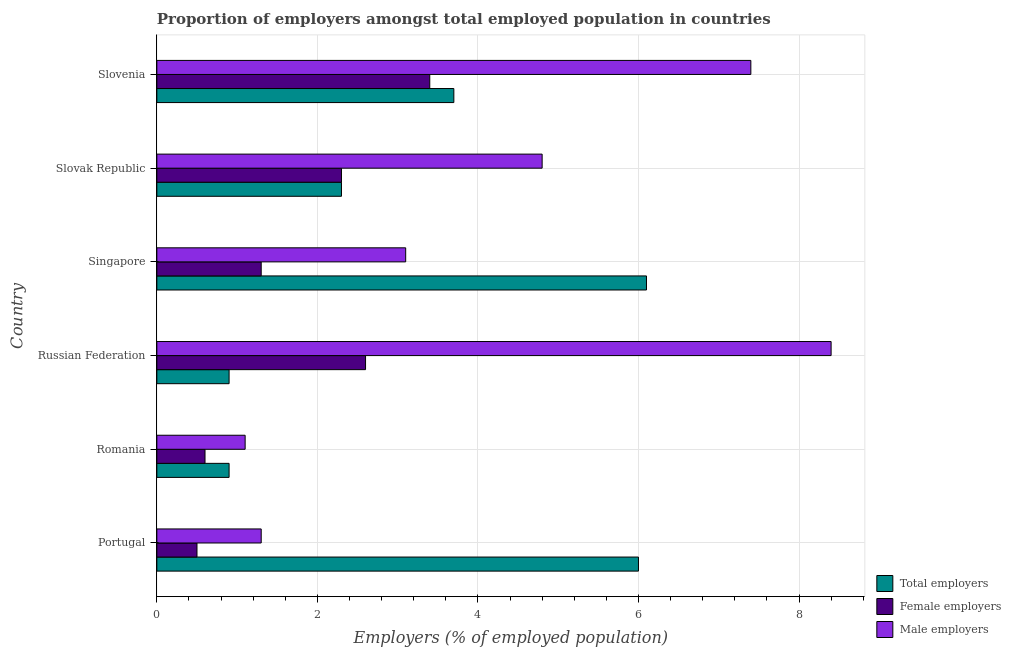How many different coloured bars are there?
Your response must be concise. 3. Are the number of bars per tick equal to the number of legend labels?
Give a very brief answer. Yes. What is the label of the 2nd group of bars from the top?
Provide a succinct answer. Slovak Republic. What is the percentage of total employers in Slovak Republic?
Your answer should be compact. 2.3. Across all countries, what is the maximum percentage of male employers?
Make the answer very short. 8.4. Across all countries, what is the minimum percentage of male employers?
Give a very brief answer. 1.1. In which country was the percentage of female employers maximum?
Offer a very short reply. Slovenia. In which country was the percentage of female employers minimum?
Provide a short and direct response. Portugal. What is the total percentage of female employers in the graph?
Your answer should be very brief. 10.7. What is the difference between the percentage of male employers in Russian Federation and the percentage of total employers in Slovenia?
Keep it short and to the point. 4.7. What is the average percentage of total employers per country?
Your answer should be very brief. 3.32. What is the difference between the percentage of total employers and percentage of female employers in Slovenia?
Make the answer very short. 0.3. Is the percentage of female employers in Portugal less than that in Singapore?
Your answer should be compact. Yes. What is the difference between the highest and the second highest percentage of female employers?
Your answer should be very brief. 0.8. What is the difference between the highest and the lowest percentage of male employers?
Provide a short and direct response. 7.3. What does the 1st bar from the top in Portugal represents?
Keep it short and to the point. Male employers. What does the 2nd bar from the bottom in Singapore represents?
Ensure brevity in your answer.  Female employers. Is it the case that in every country, the sum of the percentage of total employers and percentage of female employers is greater than the percentage of male employers?
Provide a short and direct response. No. How many bars are there?
Provide a short and direct response. 18. Are all the bars in the graph horizontal?
Keep it short and to the point. Yes. How many countries are there in the graph?
Keep it short and to the point. 6. Are the values on the major ticks of X-axis written in scientific E-notation?
Keep it short and to the point. No. Does the graph contain any zero values?
Provide a succinct answer. No. Does the graph contain grids?
Offer a very short reply. Yes. How many legend labels are there?
Offer a very short reply. 3. How are the legend labels stacked?
Provide a short and direct response. Vertical. What is the title of the graph?
Your response must be concise. Proportion of employers amongst total employed population in countries. Does "Maunufacturing" appear as one of the legend labels in the graph?
Keep it short and to the point. No. What is the label or title of the X-axis?
Offer a terse response. Employers (% of employed population). What is the label or title of the Y-axis?
Make the answer very short. Country. What is the Employers (% of employed population) in Female employers in Portugal?
Provide a short and direct response. 0.5. What is the Employers (% of employed population) in Male employers in Portugal?
Make the answer very short. 1.3. What is the Employers (% of employed population) of Total employers in Romania?
Your answer should be very brief. 0.9. What is the Employers (% of employed population) of Female employers in Romania?
Your answer should be very brief. 0.6. What is the Employers (% of employed population) of Male employers in Romania?
Keep it short and to the point. 1.1. What is the Employers (% of employed population) in Total employers in Russian Federation?
Provide a succinct answer. 0.9. What is the Employers (% of employed population) of Female employers in Russian Federation?
Give a very brief answer. 2.6. What is the Employers (% of employed population) in Male employers in Russian Federation?
Keep it short and to the point. 8.4. What is the Employers (% of employed population) of Total employers in Singapore?
Keep it short and to the point. 6.1. What is the Employers (% of employed population) of Female employers in Singapore?
Your answer should be very brief. 1.3. What is the Employers (% of employed population) in Male employers in Singapore?
Provide a short and direct response. 3.1. What is the Employers (% of employed population) of Total employers in Slovak Republic?
Your answer should be compact. 2.3. What is the Employers (% of employed population) of Female employers in Slovak Republic?
Offer a very short reply. 2.3. What is the Employers (% of employed population) in Male employers in Slovak Republic?
Your answer should be compact. 4.8. What is the Employers (% of employed population) of Total employers in Slovenia?
Provide a succinct answer. 3.7. What is the Employers (% of employed population) of Female employers in Slovenia?
Keep it short and to the point. 3.4. What is the Employers (% of employed population) in Male employers in Slovenia?
Offer a terse response. 7.4. Across all countries, what is the maximum Employers (% of employed population) in Total employers?
Ensure brevity in your answer.  6.1. Across all countries, what is the maximum Employers (% of employed population) of Female employers?
Give a very brief answer. 3.4. Across all countries, what is the maximum Employers (% of employed population) of Male employers?
Offer a very short reply. 8.4. Across all countries, what is the minimum Employers (% of employed population) in Total employers?
Offer a terse response. 0.9. Across all countries, what is the minimum Employers (% of employed population) of Male employers?
Give a very brief answer. 1.1. What is the total Employers (% of employed population) in Total employers in the graph?
Make the answer very short. 19.9. What is the total Employers (% of employed population) of Male employers in the graph?
Provide a short and direct response. 26.1. What is the difference between the Employers (% of employed population) in Female employers in Portugal and that in Romania?
Keep it short and to the point. -0.1. What is the difference between the Employers (% of employed population) in Male employers in Portugal and that in Romania?
Your answer should be very brief. 0.2. What is the difference between the Employers (% of employed population) of Female employers in Portugal and that in Russian Federation?
Make the answer very short. -2.1. What is the difference between the Employers (% of employed population) of Total employers in Portugal and that in Singapore?
Give a very brief answer. -0.1. What is the difference between the Employers (% of employed population) of Total employers in Portugal and that in Slovenia?
Provide a succinct answer. 2.3. What is the difference between the Employers (% of employed population) of Female employers in Portugal and that in Slovenia?
Offer a terse response. -2.9. What is the difference between the Employers (% of employed population) in Male employers in Romania and that in Russian Federation?
Your response must be concise. -7.3. What is the difference between the Employers (% of employed population) of Female employers in Romania and that in Singapore?
Make the answer very short. -0.7. What is the difference between the Employers (% of employed population) of Male employers in Romania and that in Singapore?
Offer a terse response. -2. What is the difference between the Employers (% of employed population) of Total employers in Romania and that in Slovak Republic?
Offer a terse response. -1.4. What is the difference between the Employers (% of employed population) in Female employers in Romania and that in Slovak Republic?
Your response must be concise. -1.7. What is the difference between the Employers (% of employed population) in Total employers in Romania and that in Slovenia?
Make the answer very short. -2.8. What is the difference between the Employers (% of employed population) in Female employers in Romania and that in Slovenia?
Your response must be concise. -2.8. What is the difference between the Employers (% of employed population) of Total employers in Russian Federation and that in Singapore?
Your answer should be very brief. -5.2. What is the difference between the Employers (% of employed population) of Male employers in Russian Federation and that in Singapore?
Provide a short and direct response. 5.3. What is the difference between the Employers (% of employed population) in Total employers in Russian Federation and that in Slovenia?
Ensure brevity in your answer.  -2.8. What is the difference between the Employers (% of employed population) of Female employers in Russian Federation and that in Slovenia?
Give a very brief answer. -0.8. What is the difference between the Employers (% of employed population) of Male employers in Singapore and that in Slovak Republic?
Your response must be concise. -1.7. What is the difference between the Employers (% of employed population) of Total employers in Singapore and that in Slovenia?
Keep it short and to the point. 2.4. What is the difference between the Employers (% of employed population) of Total employers in Portugal and the Employers (% of employed population) of Female employers in Romania?
Give a very brief answer. 5.4. What is the difference between the Employers (% of employed population) of Total employers in Portugal and the Employers (% of employed population) of Male employers in Romania?
Keep it short and to the point. 4.9. What is the difference between the Employers (% of employed population) in Total employers in Portugal and the Employers (% of employed population) in Female employers in Russian Federation?
Offer a terse response. 3.4. What is the difference between the Employers (% of employed population) of Total employers in Portugal and the Employers (% of employed population) of Male employers in Russian Federation?
Give a very brief answer. -2.4. What is the difference between the Employers (% of employed population) of Female employers in Portugal and the Employers (% of employed population) of Male employers in Russian Federation?
Give a very brief answer. -7.9. What is the difference between the Employers (% of employed population) of Total employers in Portugal and the Employers (% of employed population) of Male employers in Singapore?
Give a very brief answer. 2.9. What is the difference between the Employers (% of employed population) of Female employers in Portugal and the Employers (% of employed population) of Male employers in Singapore?
Make the answer very short. -2.6. What is the difference between the Employers (% of employed population) in Total employers in Portugal and the Employers (% of employed population) in Female employers in Slovak Republic?
Ensure brevity in your answer.  3.7. What is the difference between the Employers (% of employed population) of Female employers in Portugal and the Employers (% of employed population) of Male employers in Slovak Republic?
Make the answer very short. -4.3. What is the difference between the Employers (% of employed population) of Female employers in Portugal and the Employers (% of employed population) of Male employers in Slovenia?
Keep it short and to the point. -6.9. What is the difference between the Employers (% of employed population) of Total employers in Romania and the Employers (% of employed population) of Male employers in Russian Federation?
Your answer should be very brief. -7.5. What is the difference between the Employers (% of employed population) of Female employers in Romania and the Employers (% of employed population) of Male employers in Russian Federation?
Your answer should be very brief. -7.8. What is the difference between the Employers (% of employed population) in Total employers in Romania and the Employers (% of employed population) in Female employers in Singapore?
Provide a short and direct response. -0.4. What is the difference between the Employers (% of employed population) of Total employers in Romania and the Employers (% of employed population) of Male employers in Singapore?
Offer a terse response. -2.2. What is the difference between the Employers (% of employed population) in Total employers in Romania and the Employers (% of employed population) in Female employers in Slovak Republic?
Offer a terse response. -1.4. What is the difference between the Employers (% of employed population) of Total employers in Romania and the Employers (% of employed population) of Male employers in Slovak Republic?
Offer a terse response. -3.9. What is the difference between the Employers (% of employed population) in Female employers in Romania and the Employers (% of employed population) in Male employers in Slovak Republic?
Provide a succinct answer. -4.2. What is the difference between the Employers (% of employed population) in Total employers in Russian Federation and the Employers (% of employed population) in Male employers in Singapore?
Your answer should be compact. -2.2. What is the difference between the Employers (% of employed population) of Female employers in Russian Federation and the Employers (% of employed population) of Male employers in Singapore?
Ensure brevity in your answer.  -0.5. What is the difference between the Employers (% of employed population) in Total employers in Russian Federation and the Employers (% of employed population) in Male employers in Slovenia?
Offer a terse response. -6.5. What is the difference between the Employers (% of employed population) in Total employers in Singapore and the Employers (% of employed population) in Female employers in Slovak Republic?
Offer a very short reply. 3.8. What is the difference between the Employers (% of employed population) of Total employers in Singapore and the Employers (% of employed population) of Male employers in Slovenia?
Provide a short and direct response. -1.3. What is the average Employers (% of employed population) of Total employers per country?
Provide a succinct answer. 3.32. What is the average Employers (% of employed population) of Female employers per country?
Keep it short and to the point. 1.78. What is the average Employers (% of employed population) of Male employers per country?
Your response must be concise. 4.35. What is the difference between the Employers (% of employed population) in Total employers and Employers (% of employed population) in Male employers in Portugal?
Offer a terse response. 4.7. What is the difference between the Employers (% of employed population) of Total employers and Employers (% of employed population) of Female employers in Romania?
Make the answer very short. 0.3. What is the difference between the Employers (% of employed population) of Total employers and Employers (% of employed population) of Male employers in Russian Federation?
Make the answer very short. -7.5. What is the difference between the Employers (% of employed population) in Female employers and Employers (% of employed population) in Male employers in Russian Federation?
Your response must be concise. -5.8. What is the difference between the Employers (% of employed population) of Female employers and Employers (% of employed population) of Male employers in Singapore?
Your answer should be compact. -1.8. What is the difference between the Employers (% of employed population) of Total employers and Employers (% of employed population) of Male employers in Slovak Republic?
Ensure brevity in your answer.  -2.5. What is the difference between the Employers (% of employed population) of Female employers and Employers (% of employed population) of Male employers in Slovak Republic?
Offer a terse response. -2.5. What is the difference between the Employers (% of employed population) in Total employers and Employers (% of employed population) in Male employers in Slovenia?
Make the answer very short. -3.7. What is the difference between the Employers (% of employed population) in Female employers and Employers (% of employed population) in Male employers in Slovenia?
Offer a very short reply. -4. What is the ratio of the Employers (% of employed population) of Total employers in Portugal to that in Romania?
Make the answer very short. 6.67. What is the ratio of the Employers (% of employed population) of Female employers in Portugal to that in Romania?
Ensure brevity in your answer.  0.83. What is the ratio of the Employers (% of employed population) in Male employers in Portugal to that in Romania?
Give a very brief answer. 1.18. What is the ratio of the Employers (% of employed population) in Total employers in Portugal to that in Russian Federation?
Offer a terse response. 6.67. What is the ratio of the Employers (% of employed population) of Female employers in Portugal to that in Russian Federation?
Your response must be concise. 0.19. What is the ratio of the Employers (% of employed population) of Male employers in Portugal to that in Russian Federation?
Make the answer very short. 0.15. What is the ratio of the Employers (% of employed population) in Total employers in Portugal to that in Singapore?
Offer a terse response. 0.98. What is the ratio of the Employers (% of employed population) of Female employers in Portugal to that in Singapore?
Your response must be concise. 0.38. What is the ratio of the Employers (% of employed population) of Male employers in Portugal to that in Singapore?
Ensure brevity in your answer.  0.42. What is the ratio of the Employers (% of employed population) in Total employers in Portugal to that in Slovak Republic?
Offer a terse response. 2.61. What is the ratio of the Employers (% of employed population) of Female employers in Portugal to that in Slovak Republic?
Your response must be concise. 0.22. What is the ratio of the Employers (% of employed population) of Male employers in Portugal to that in Slovak Republic?
Give a very brief answer. 0.27. What is the ratio of the Employers (% of employed population) in Total employers in Portugal to that in Slovenia?
Give a very brief answer. 1.62. What is the ratio of the Employers (% of employed population) of Female employers in Portugal to that in Slovenia?
Provide a succinct answer. 0.15. What is the ratio of the Employers (% of employed population) in Male employers in Portugal to that in Slovenia?
Your answer should be very brief. 0.18. What is the ratio of the Employers (% of employed population) in Female employers in Romania to that in Russian Federation?
Make the answer very short. 0.23. What is the ratio of the Employers (% of employed population) in Male employers in Romania to that in Russian Federation?
Make the answer very short. 0.13. What is the ratio of the Employers (% of employed population) of Total employers in Romania to that in Singapore?
Your answer should be compact. 0.15. What is the ratio of the Employers (% of employed population) of Female employers in Romania to that in Singapore?
Your answer should be compact. 0.46. What is the ratio of the Employers (% of employed population) in Male employers in Romania to that in Singapore?
Make the answer very short. 0.35. What is the ratio of the Employers (% of employed population) of Total employers in Romania to that in Slovak Republic?
Offer a very short reply. 0.39. What is the ratio of the Employers (% of employed population) in Female employers in Romania to that in Slovak Republic?
Provide a short and direct response. 0.26. What is the ratio of the Employers (% of employed population) in Male employers in Romania to that in Slovak Republic?
Provide a short and direct response. 0.23. What is the ratio of the Employers (% of employed population) of Total employers in Romania to that in Slovenia?
Your response must be concise. 0.24. What is the ratio of the Employers (% of employed population) of Female employers in Romania to that in Slovenia?
Make the answer very short. 0.18. What is the ratio of the Employers (% of employed population) in Male employers in Romania to that in Slovenia?
Your answer should be compact. 0.15. What is the ratio of the Employers (% of employed population) in Total employers in Russian Federation to that in Singapore?
Give a very brief answer. 0.15. What is the ratio of the Employers (% of employed population) in Male employers in Russian Federation to that in Singapore?
Provide a short and direct response. 2.71. What is the ratio of the Employers (% of employed population) in Total employers in Russian Federation to that in Slovak Republic?
Make the answer very short. 0.39. What is the ratio of the Employers (% of employed population) in Female employers in Russian Federation to that in Slovak Republic?
Provide a succinct answer. 1.13. What is the ratio of the Employers (% of employed population) in Total employers in Russian Federation to that in Slovenia?
Ensure brevity in your answer.  0.24. What is the ratio of the Employers (% of employed population) of Female employers in Russian Federation to that in Slovenia?
Make the answer very short. 0.76. What is the ratio of the Employers (% of employed population) of Male employers in Russian Federation to that in Slovenia?
Make the answer very short. 1.14. What is the ratio of the Employers (% of employed population) in Total employers in Singapore to that in Slovak Republic?
Offer a very short reply. 2.65. What is the ratio of the Employers (% of employed population) in Female employers in Singapore to that in Slovak Republic?
Provide a succinct answer. 0.57. What is the ratio of the Employers (% of employed population) of Male employers in Singapore to that in Slovak Republic?
Offer a very short reply. 0.65. What is the ratio of the Employers (% of employed population) in Total employers in Singapore to that in Slovenia?
Make the answer very short. 1.65. What is the ratio of the Employers (% of employed population) in Female employers in Singapore to that in Slovenia?
Your answer should be compact. 0.38. What is the ratio of the Employers (% of employed population) of Male employers in Singapore to that in Slovenia?
Your answer should be very brief. 0.42. What is the ratio of the Employers (% of employed population) of Total employers in Slovak Republic to that in Slovenia?
Give a very brief answer. 0.62. What is the ratio of the Employers (% of employed population) of Female employers in Slovak Republic to that in Slovenia?
Provide a succinct answer. 0.68. What is the ratio of the Employers (% of employed population) in Male employers in Slovak Republic to that in Slovenia?
Make the answer very short. 0.65. What is the difference between the highest and the second highest Employers (% of employed population) in Total employers?
Provide a succinct answer. 0.1. What is the difference between the highest and the second highest Employers (% of employed population) of Female employers?
Keep it short and to the point. 0.8. 